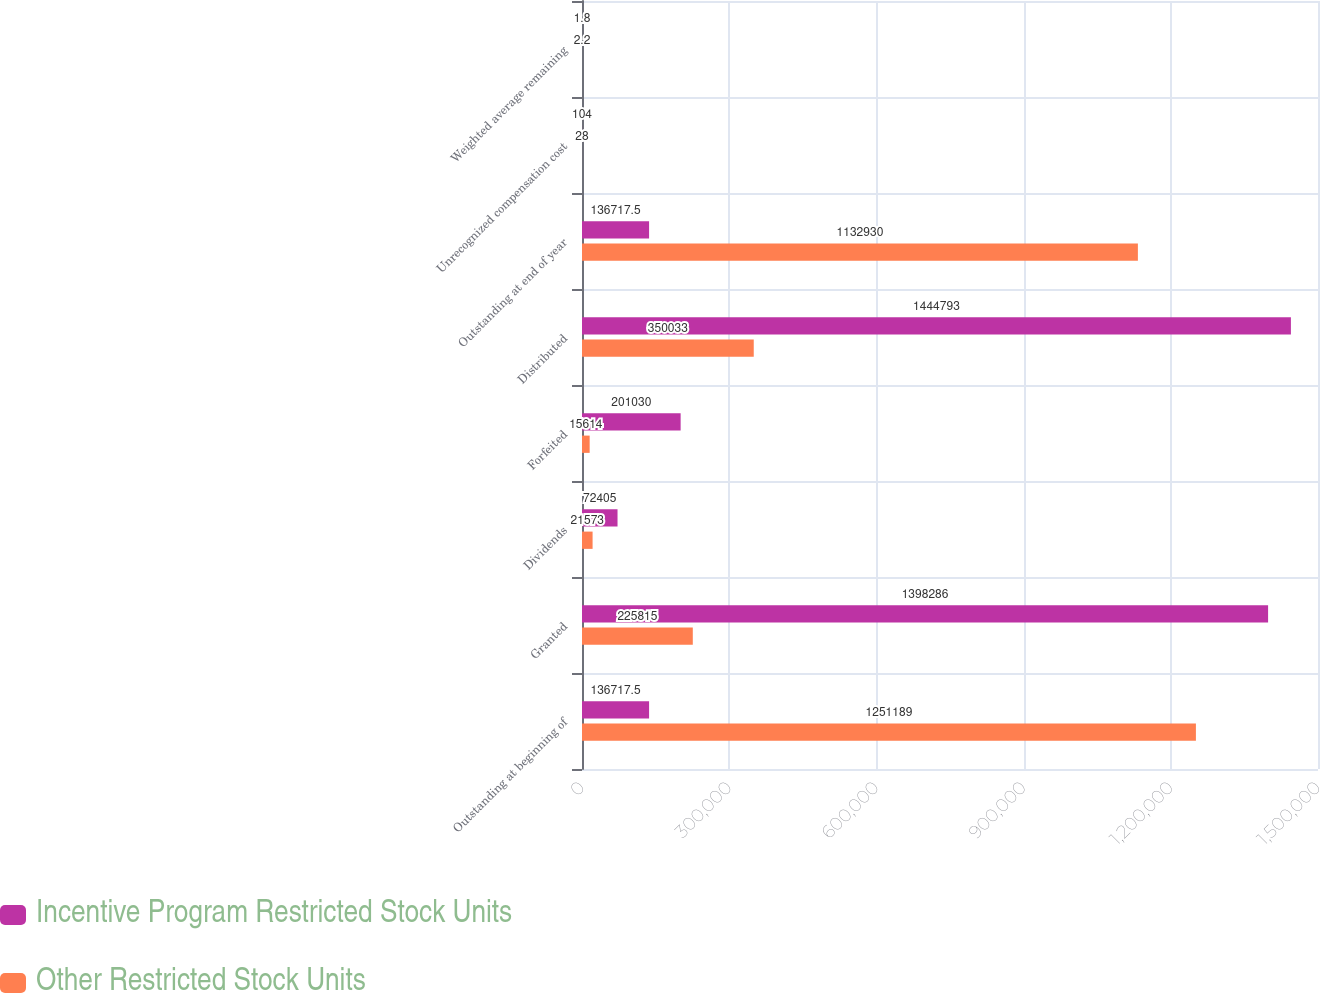Convert chart. <chart><loc_0><loc_0><loc_500><loc_500><stacked_bar_chart><ecel><fcel>Outstanding at beginning of<fcel>Granted<fcel>Dividends<fcel>Forfeited<fcel>Distributed<fcel>Outstanding at end of year<fcel>Unrecognized compensation cost<fcel>Weighted average remaining<nl><fcel>Incentive Program Restricted Stock Units<fcel>136718<fcel>1.39829e+06<fcel>72405<fcel>201030<fcel>1.44479e+06<fcel>136718<fcel>104<fcel>1.8<nl><fcel>Other Restricted Stock Units<fcel>1.25119e+06<fcel>225815<fcel>21573<fcel>15614<fcel>350033<fcel>1.13293e+06<fcel>28<fcel>2.2<nl></chart> 